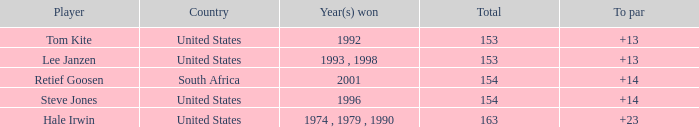What is the sum for south africa with a par exceeding 14? None. 